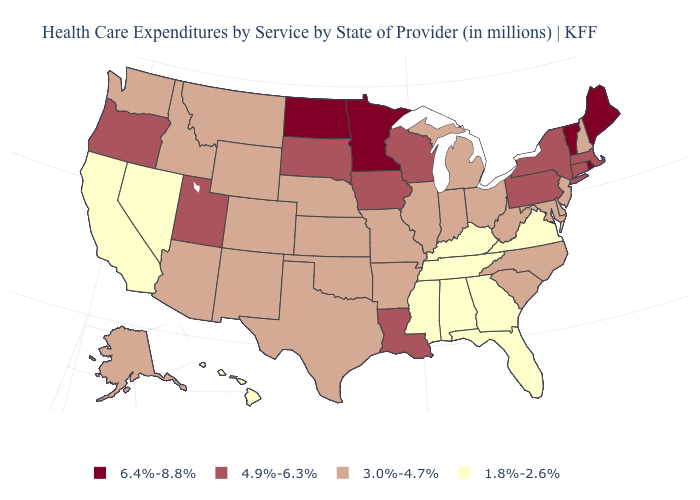Among the states that border New Hampshire , does Massachusetts have the lowest value?
Be succinct. Yes. What is the value of Tennessee?
Short answer required. 1.8%-2.6%. Among the states that border New York , does Vermont have the lowest value?
Short answer required. No. What is the lowest value in the West?
Keep it brief. 1.8%-2.6%. Is the legend a continuous bar?
Answer briefly. No. Does Rhode Island have the highest value in the USA?
Answer briefly. Yes. Does New York have the highest value in the Northeast?
Short answer required. No. What is the highest value in the USA?
Short answer required. 6.4%-8.8%. What is the value of Maryland?
Give a very brief answer. 3.0%-4.7%. Does Florida have a higher value than Hawaii?
Be succinct. No. Does Delaware have a lower value than Louisiana?
Concise answer only. Yes. Among the states that border Maryland , which have the highest value?
Answer briefly. Pennsylvania. Name the states that have a value in the range 4.9%-6.3%?
Keep it brief. Connecticut, Iowa, Louisiana, Massachusetts, New York, Oregon, Pennsylvania, South Dakota, Utah, Wisconsin. What is the lowest value in the Northeast?
Give a very brief answer. 3.0%-4.7%. 